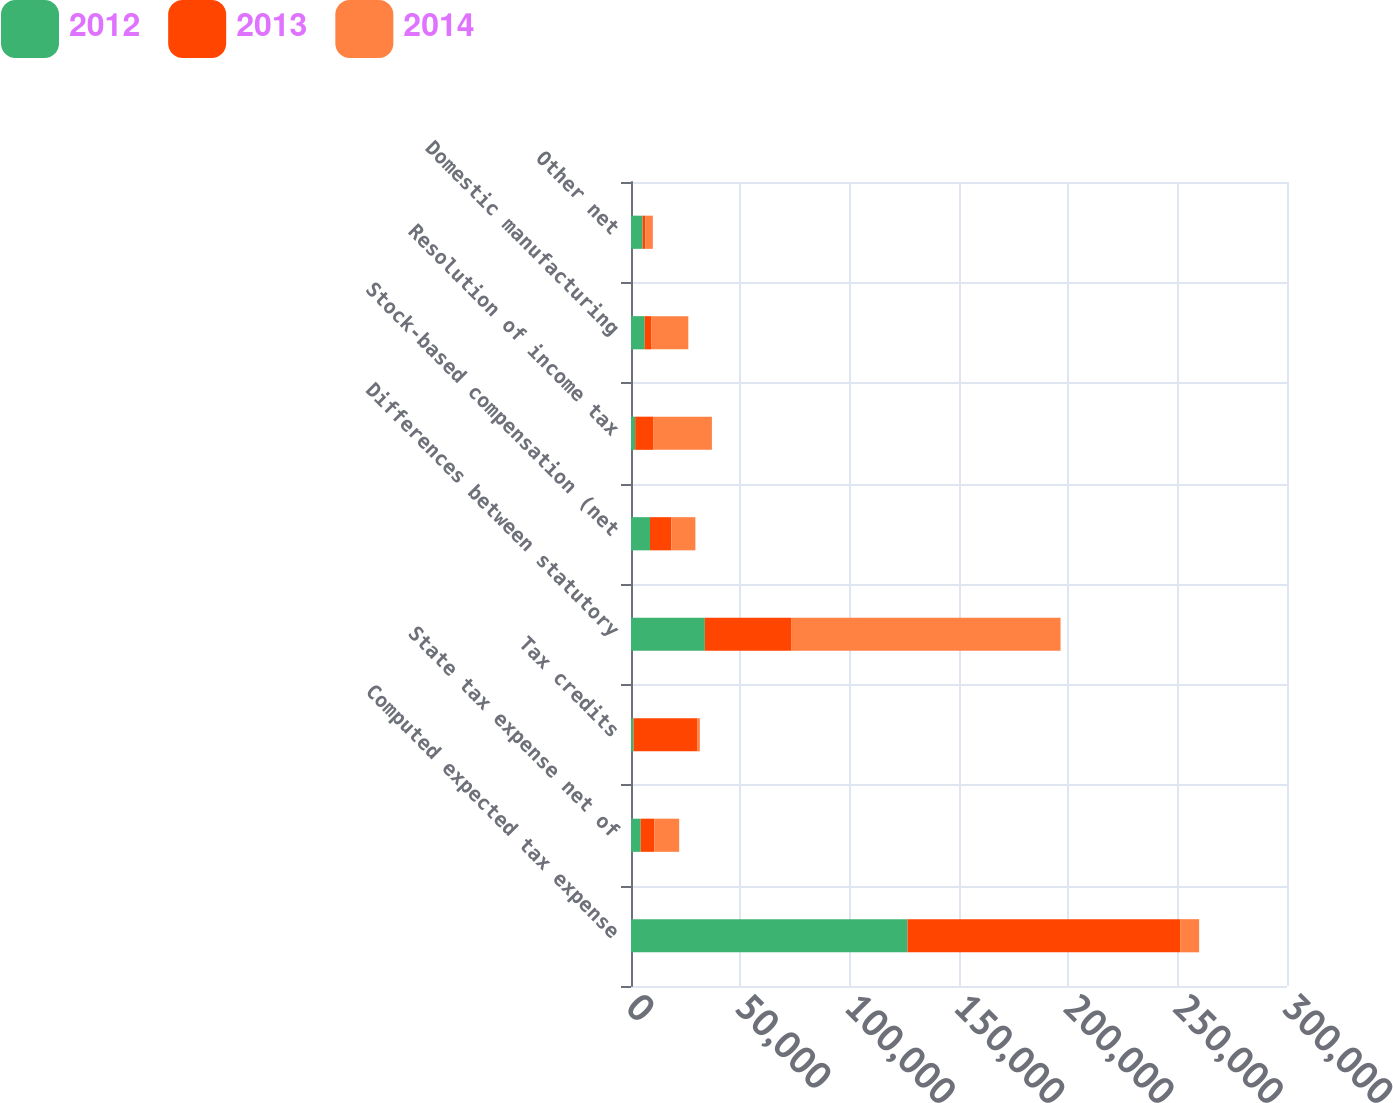Convert chart. <chart><loc_0><loc_0><loc_500><loc_500><stacked_bar_chart><ecel><fcel>Computed expected tax expense<fcel>State tax expense net of<fcel>Tax credits<fcel>Differences between statutory<fcel>Stock-based compensation (net<fcel>Resolution of income tax<fcel>Domestic manufacturing<fcel>Other net<nl><fcel>2012<fcel>126481<fcel>4411<fcel>1166<fcel>33769<fcel>8688<fcel>1896<fcel>6272<fcel>5326<nl><fcel>2013<fcel>124649<fcel>6304<fcel>29087<fcel>39678<fcel>9783<fcel>8421<fcel>2929<fcel>1306<nl><fcel>2014<fcel>8688<fcel>11320<fcel>1226<fcel>122999<fcel>10976<fcel>26687<fcel>17010<fcel>3362<nl></chart> 